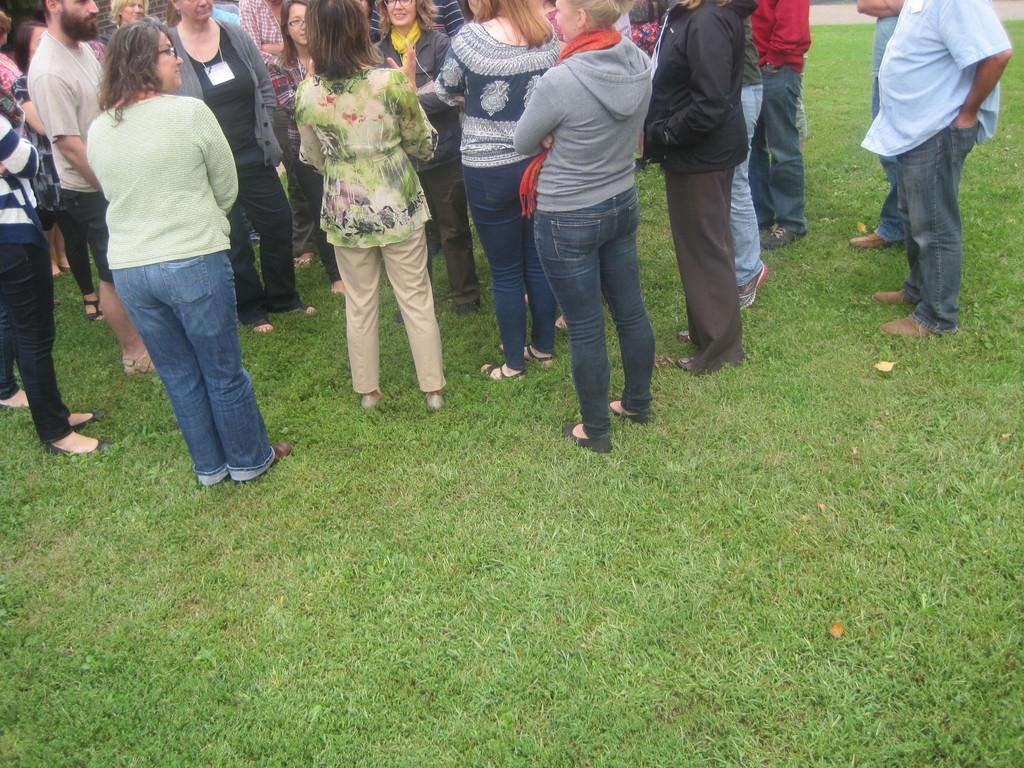Describe this image in one or two sentences. In the image I can see some people standing on the grass. 